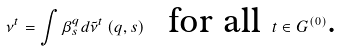<formula> <loc_0><loc_0><loc_500><loc_500>\nu ^ { t } = \int \beta _ { s } ^ { q } d \tilde { \nu } ^ { t } \left ( q , s \right ) \text { \ for all } t \in G ^ { \left ( 0 \right ) } \text {.}</formula> 